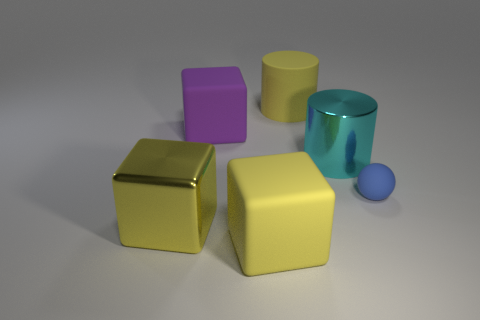Add 2 brown metal balls. How many objects exist? 8 Subtract all balls. How many objects are left? 5 Add 5 large red rubber blocks. How many large red rubber blocks exist? 5 Subtract 0 cyan spheres. How many objects are left? 6 Subtract all big objects. Subtract all big purple matte objects. How many objects are left? 0 Add 2 large yellow metal blocks. How many large yellow metal blocks are left? 3 